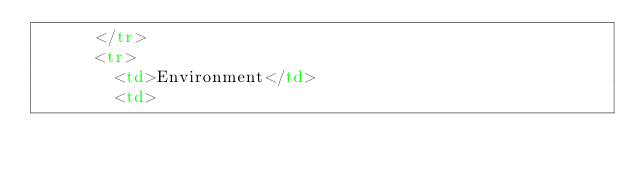Convert code to text. <code><loc_0><loc_0><loc_500><loc_500><_HTML_>      </tr>
      <tr>
        <td>Environment</td>
        <td></code> 